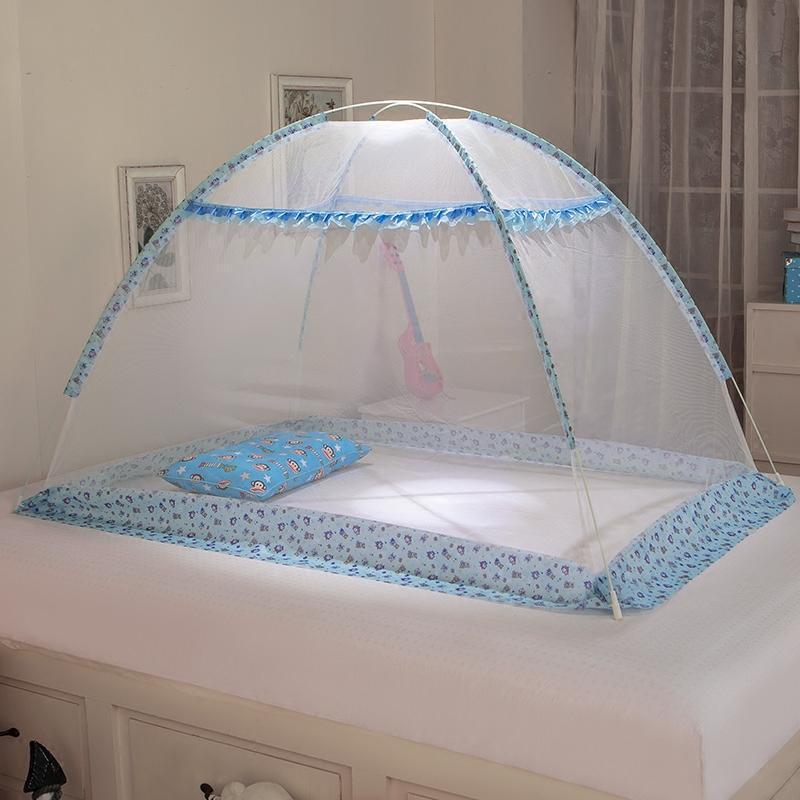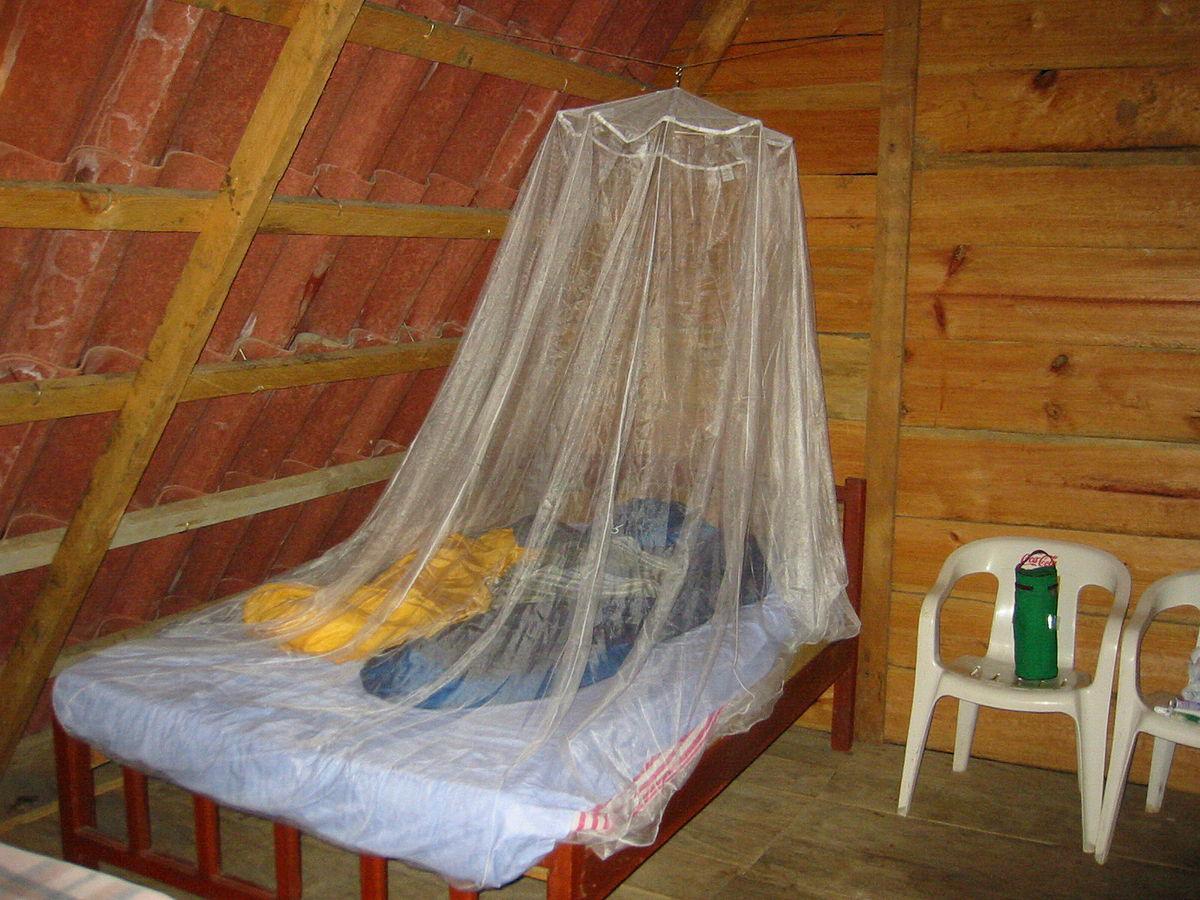The first image is the image on the left, the second image is the image on the right. Examine the images to the left and right. Is the description "The bed set in the left image has a pink canopy above it." accurate? Answer yes or no. No. The first image is the image on the left, the second image is the image on the right. Evaluate the accuracy of this statement regarding the images: "There is a pink canopy hanging over a bed". Is it true? Answer yes or no. No. 